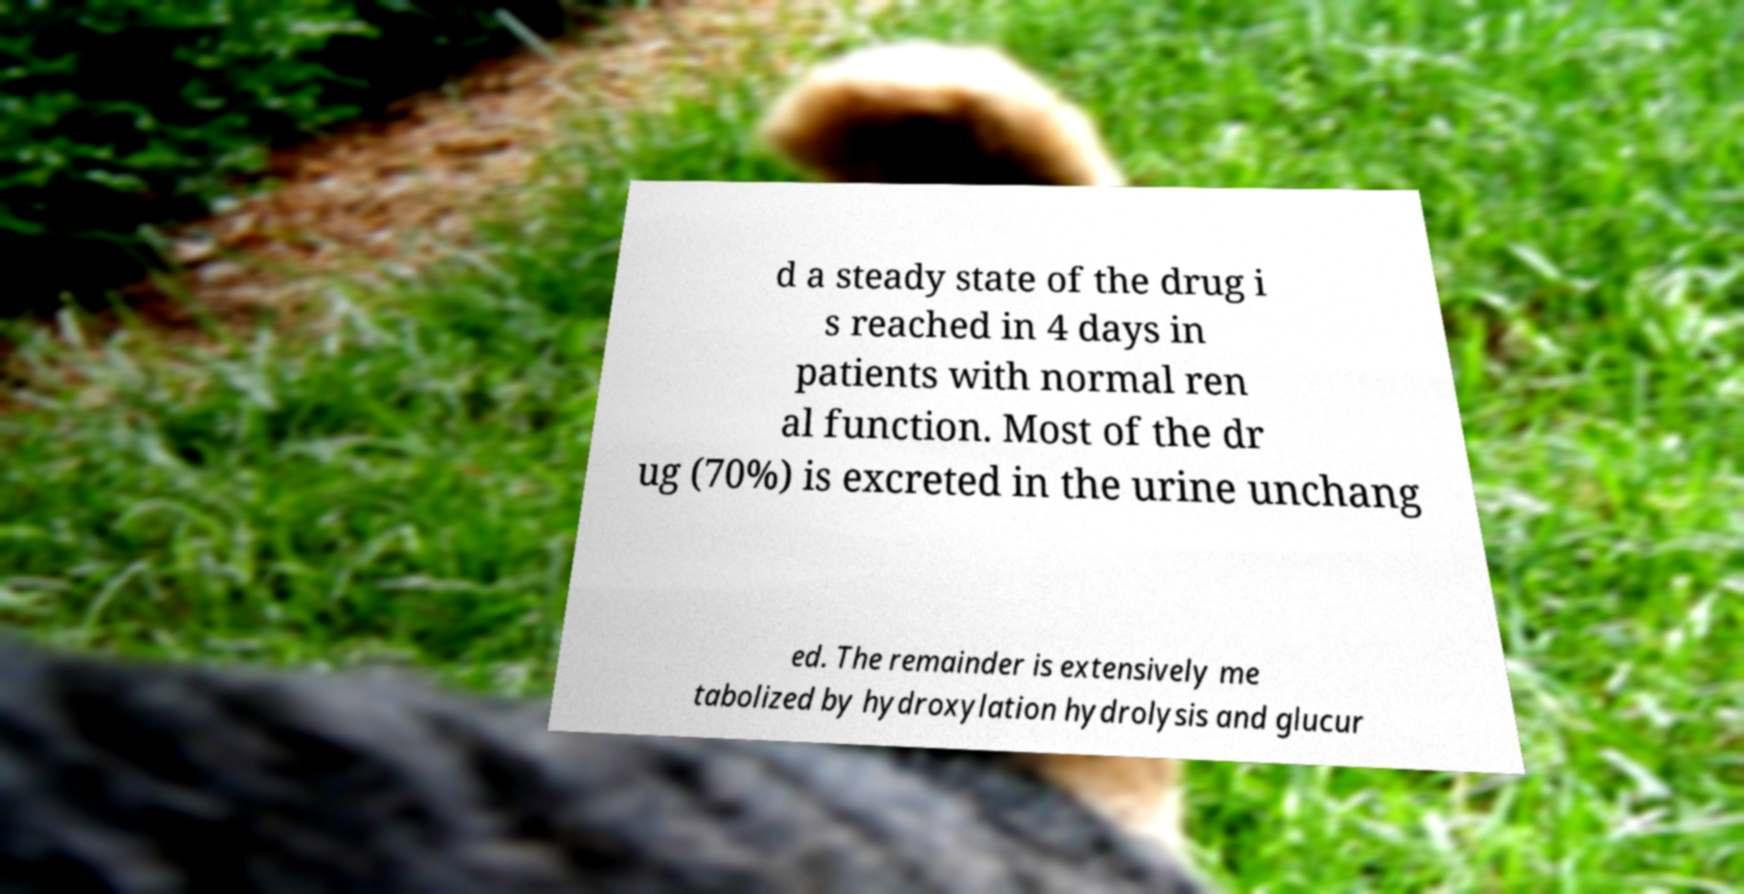Can you read and provide the text displayed in the image?This photo seems to have some interesting text. Can you extract and type it out for me? d a steady state of the drug i s reached in 4 days in patients with normal ren al function. Most of the dr ug (70%) is excreted in the urine unchang ed. The remainder is extensively me tabolized by hydroxylation hydrolysis and glucur 